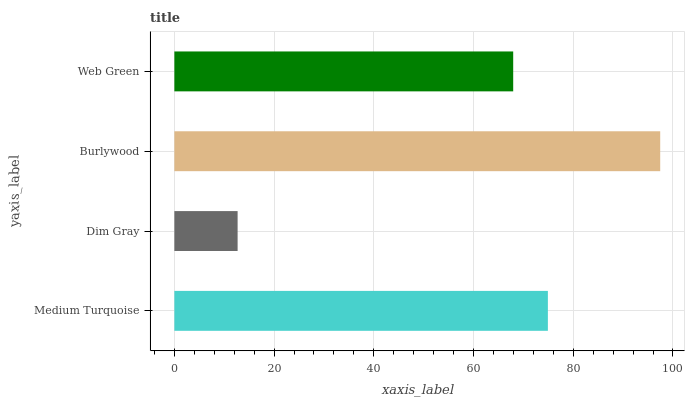Is Dim Gray the minimum?
Answer yes or no. Yes. Is Burlywood the maximum?
Answer yes or no. Yes. Is Burlywood the minimum?
Answer yes or no. No. Is Dim Gray the maximum?
Answer yes or no. No. Is Burlywood greater than Dim Gray?
Answer yes or no. Yes. Is Dim Gray less than Burlywood?
Answer yes or no. Yes. Is Dim Gray greater than Burlywood?
Answer yes or no. No. Is Burlywood less than Dim Gray?
Answer yes or no. No. Is Medium Turquoise the high median?
Answer yes or no. Yes. Is Web Green the low median?
Answer yes or no. Yes. Is Web Green the high median?
Answer yes or no. No. Is Medium Turquoise the low median?
Answer yes or no. No. 